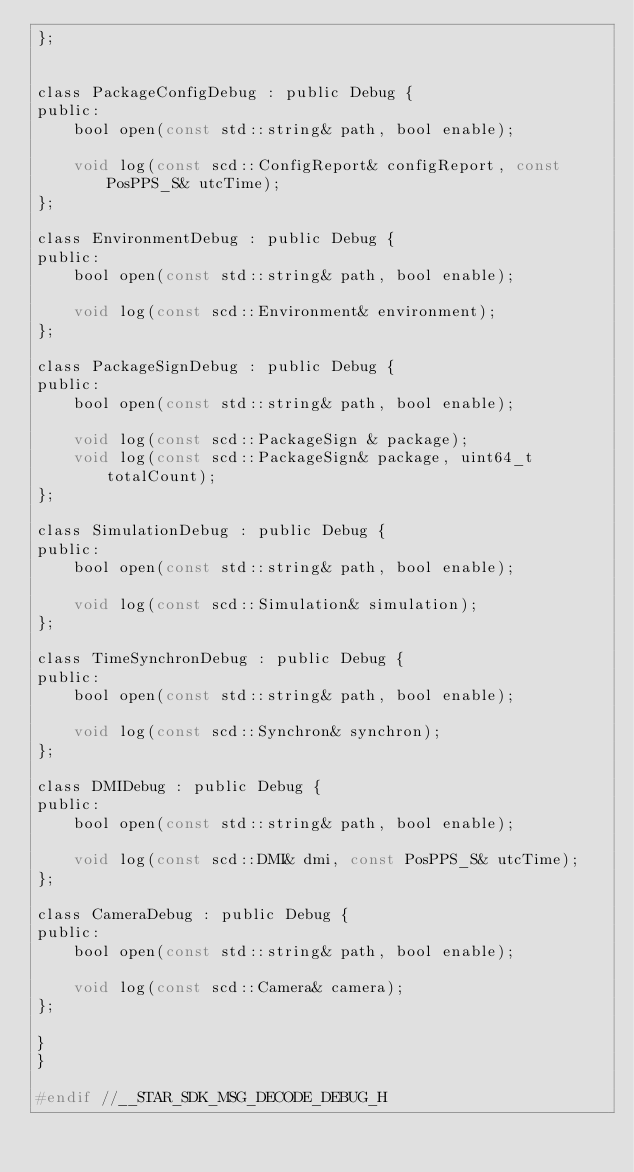Convert code to text. <code><loc_0><loc_0><loc_500><loc_500><_C_>};


class PackageConfigDebug : public Debug {
public:
    bool open(const std::string& path, bool enable);

    void log(const scd::ConfigReport& configReport, const PosPPS_S& utcTime);
};

class EnvironmentDebug : public Debug {
public:
    bool open(const std::string& path, bool enable);

    void log(const scd::Environment& environment);
};

class PackageSignDebug : public Debug {
public:
    bool open(const std::string& path, bool enable);

    void log(const scd::PackageSign & package);
    void log(const scd::PackageSign& package, uint64_t totalCount);
};

class SimulationDebug : public Debug {
public:
    bool open(const std::string& path, bool enable);

    void log(const scd::Simulation& simulation);
};

class TimeSynchronDebug : public Debug {
public:
    bool open(const std::string& path, bool enable);

    void log(const scd::Synchron& synchron);
};

class DMIDebug : public Debug {
public:
    bool open(const std::string& path, bool enable);

    void log(const scd::DMI& dmi, const PosPPS_S& utcTime);
};

class CameraDebug : public Debug {
public:
    bool open(const std::string& path, bool enable);

    void log(const scd::Camera& camera);
};

}
}

#endif //__STAR_SDK_MSG_DECODE_DEBUG_H
</code> 